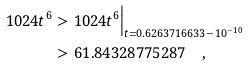Convert formula to latex. <formula><loc_0><loc_0><loc_500><loc_500>1 0 2 4 t ^ { 6 } & > 1 0 2 4 t ^ { 6 } \Big | _ { t = 0 . 6 2 6 3 7 1 6 6 3 3 - 1 0 ^ { - 1 0 } } \\ & > 6 1 . 8 4 3 2 8 7 7 5 2 8 7 \quad ,</formula> 